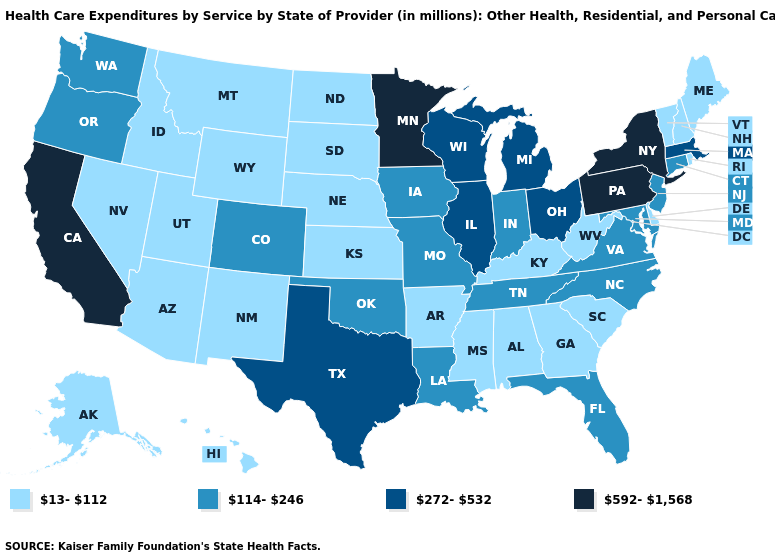Name the states that have a value in the range 13-112?
Write a very short answer. Alabama, Alaska, Arizona, Arkansas, Delaware, Georgia, Hawaii, Idaho, Kansas, Kentucky, Maine, Mississippi, Montana, Nebraska, Nevada, New Hampshire, New Mexico, North Dakota, Rhode Island, South Carolina, South Dakota, Utah, Vermont, West Virginia, Wyoming. Which states have the highest value in the USA?
Keep it brief. California, Minnesota, New York, Pennsylvania. What is the value of North Carolina?
Quick response, please. 114-246. Name the states that have a value in the range 114-246?
Be succinct. Colorado, Connecticut, Florida, Indiana, Iowa, Louisiana, Maryland, Missouri, New Jersey, North Carolina, Oklahoma, Oregon, Tennessee, Virginia, Washington. What is the lowest value in states that border Alabama?
Quick response, please. 13-112. Among the states that border Oregon , which have the highest value?
Keep it brief. California. What is the value of Kentucky?
Write a very short answer. 13-112. What is the value of Maine?
Write a very short answer. 13-112. What is the highest value in the West ?
Keep it brief. 592-1,568. What is the value of Indiana?
Write a very short answer. 114-246. Does Oregon have the lowest value in the West?
Give a very brief answer. No. How many symbols are there in the legend?
Write a very short answer. 4. What is the value of North Dakota?
Answer briefly. 13-112. Name the states that have a value in the range 272-532?
Quick response, please. Illinois, Massachusetts, Michigan, Ohio, Texas, Wisconsin. Does Kentucky have a lower value than Maine?
Answer briefly. No. 